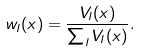Convert formula to latex. <formula><loc_0><loc_0><loc_500><loc_500>w _ { l } ( x ) = \frac { V _ { l } ( x ) } { \sum _ { l } V _ { l } ( x ) } .</formula> 